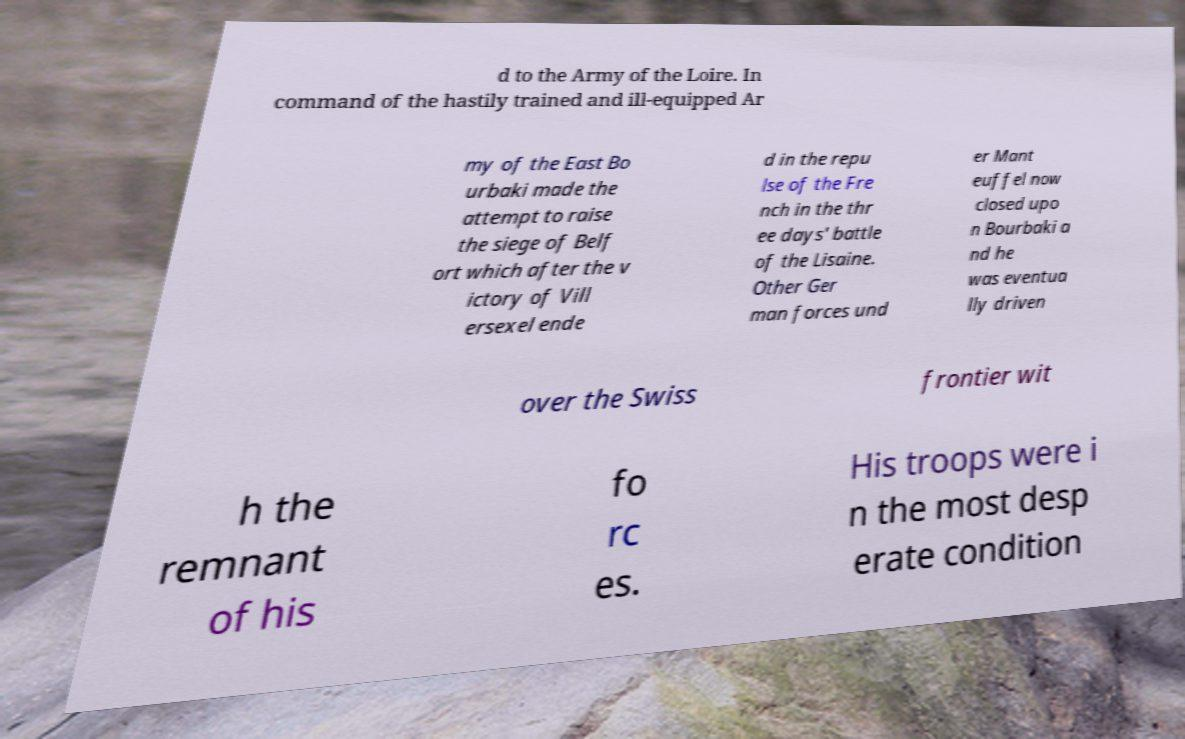Can you read and provide the text displayed in the image?This photo seems to have some interesting text. Can you extract and type it out for me? d to the Army of the Loire. In command of the hastily trained and ill-equipped Ar my of the East Bo urbaki made the attempt to raise the siege of Belf ort which after the v ictory of Vill ersexel ende d in the repu lse of the Fre nch in the thr ee days' battle of the Lisaine. Other Ger man forces und er Mant euffel now closed upo n Bourbaki a nd he was eventua lly driven over the Swiss frontier wit h the remnant of his fo rc es. His troops were i n the most desp erate condition 